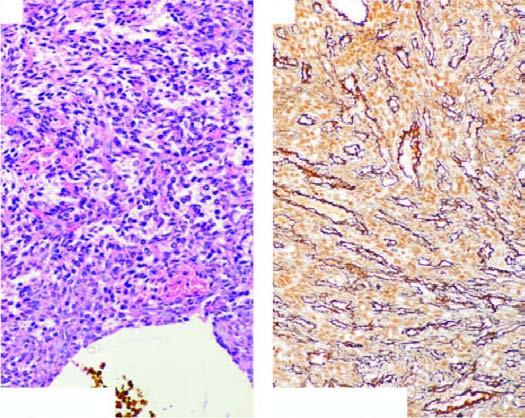do suspension of leucocytes above have bland nuclei and few mitoses?
Answer the question using a single word or phrase. No 